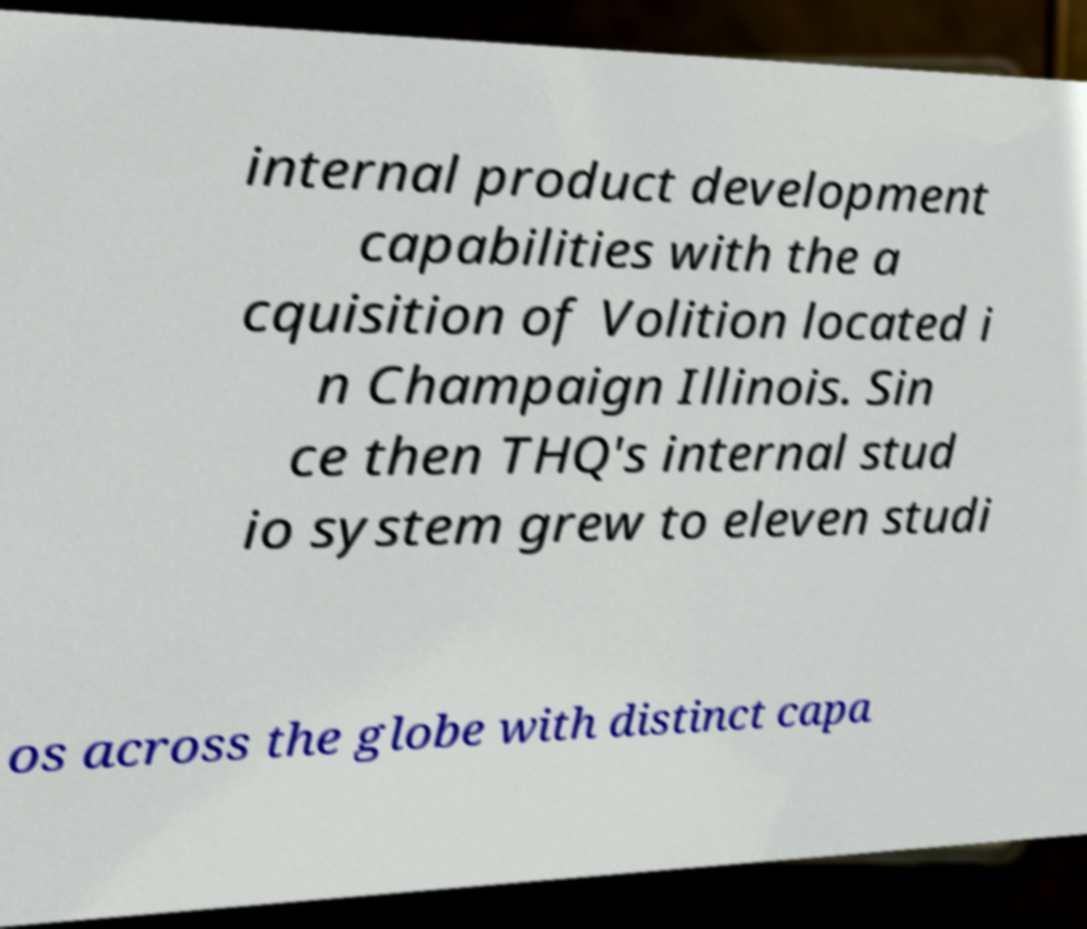What messages or text are displayed in this image? I need them in a readable, typed format. internal product development capabilities with the a cquisition of Volition located i n Champaign Illinois. Sin ce then THQ's internal stud io system grew to eleven studi os across the globe with distinct capa 